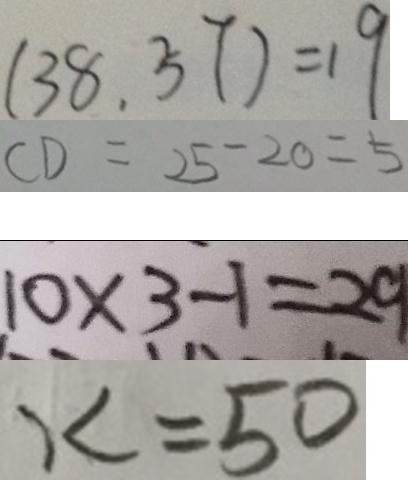<formula> <loc_0><loc_0><loc_500><loc_500>( 3 8 , 5 7 ) = 1 9 
 C D = 2 5 - 2 0 = 5 
 1 0 \times 3 - 1 = 2 9 
 x = 5 0</formula> 